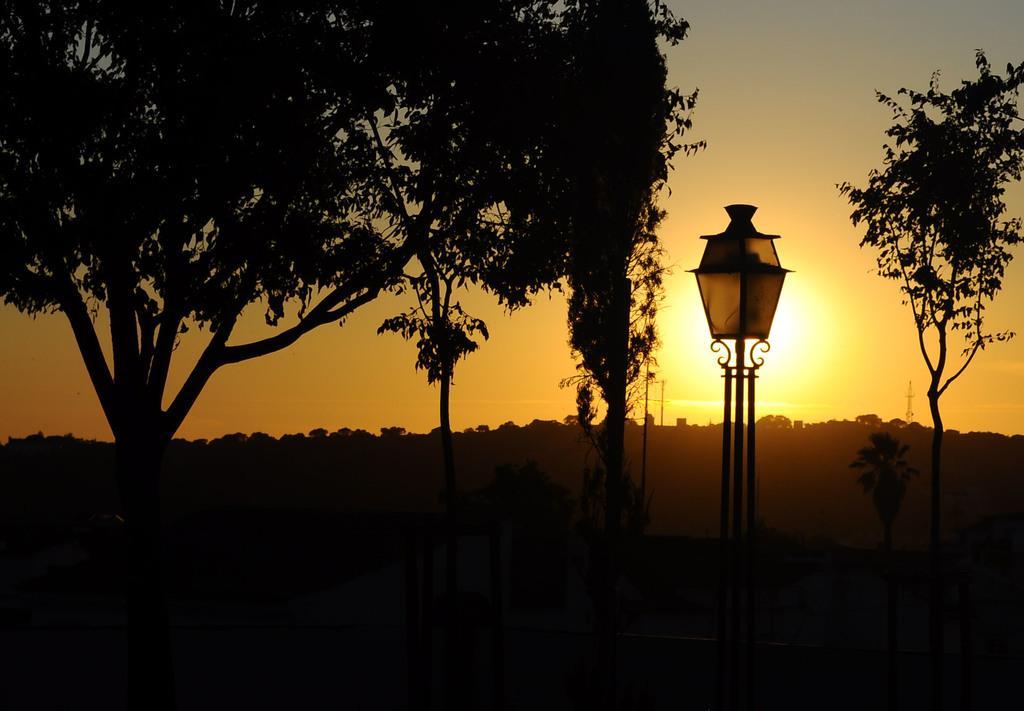Describe this image in one or two sentences. In this image there is the sky, there is the sun in the sky, there are trees, there is a streetlight on the stand. 